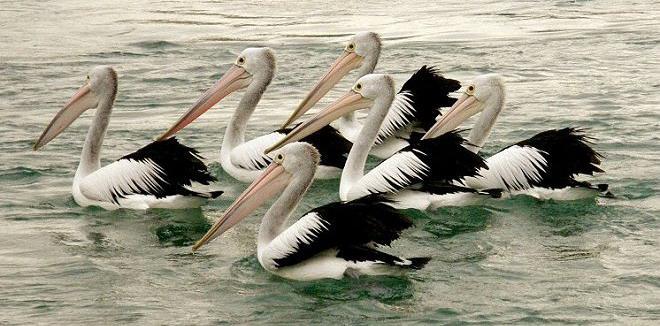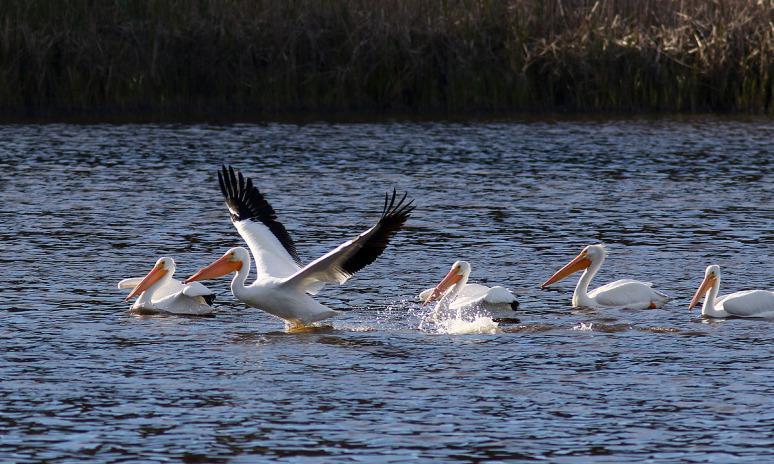The first image is the image on the left, the second image is the image on the right. For the images displayed, is the sentence "Right image shows pelicans with smaller dark birds." factually correct? Answer yes or no. No. 